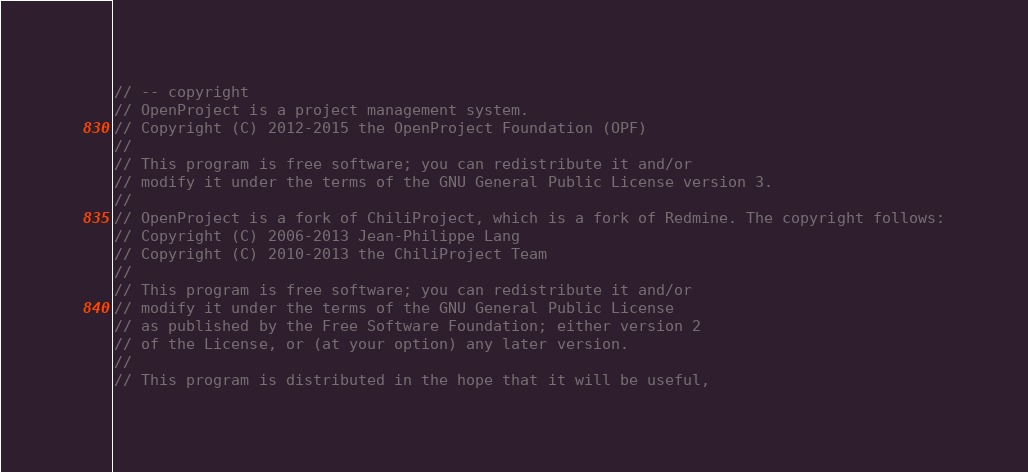<code> <loc_0><loc_0><loc_500><loc_500><_TypeScript_>// -- copyright
// OpenProject is a project management system.
// Copyright (C) 2012-2015 the OpenProject Foundation (OPF)
//
// This program is free software; you can redistribute it and/or
// modify it under the terms of the GNU General Public License version 3.
//
// OpenProject is a fork of ChiliProject, which is a fork of Redmine. The copyright follows:
// Copyright (C) 2006-2013 Jean-Philippe Lang
// Copyright (C) 2010-2013 the ChiliProject Team
//
// This program is free software; you can redistribute it and/or
// modify it under the terms of the GNU General Public License
// as published by the Free Software Foundation; either version 2
// of the License, or (at your option) any later version.
//
// This program is distributed in the hope that it will be useful,</code> 